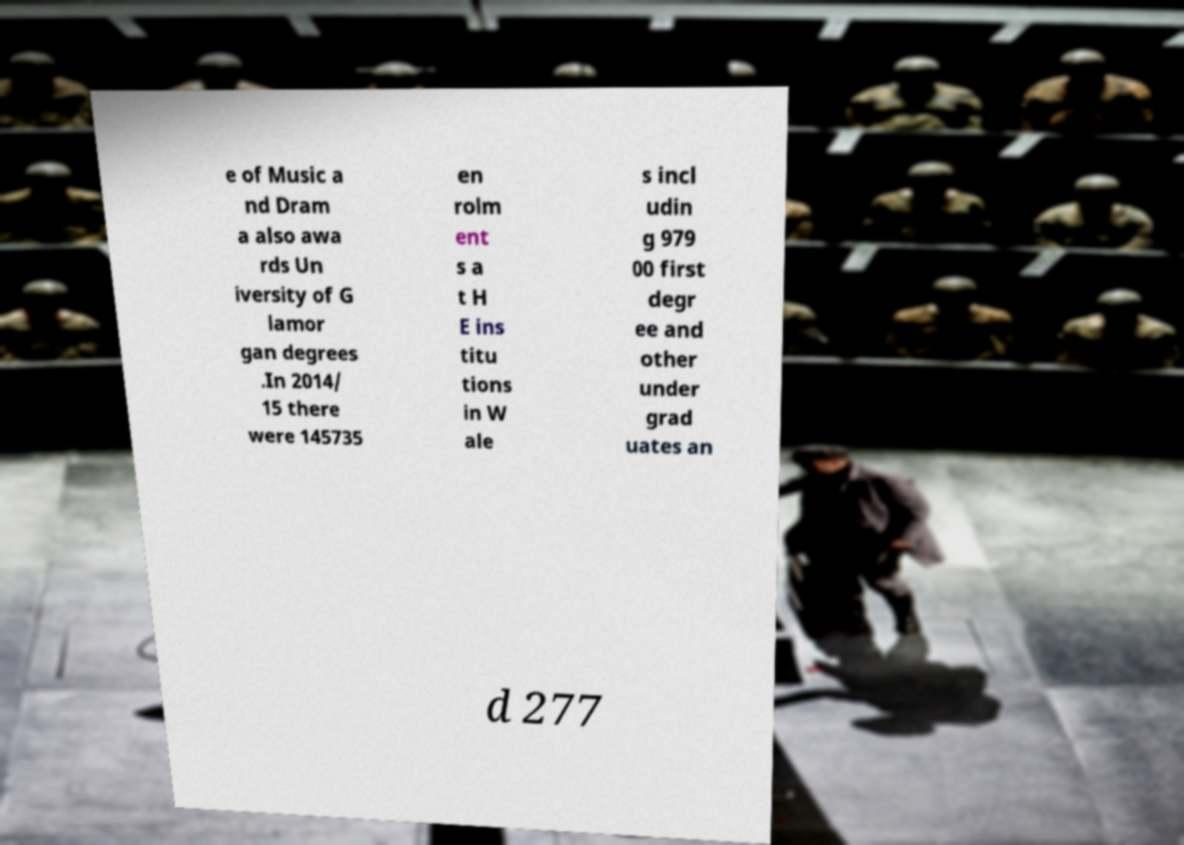What messages or text are displayed in this image? I need them in a readable, typed format. e of Music a nd Dram a also awa rds Un iversity of G lamor gan degrees .In 2014/ 15 there were 145735 en rolm ent s a t H E ins titu tions in W ale s incl udin g 979 00 first degr ee and other under grad uates an d 277 